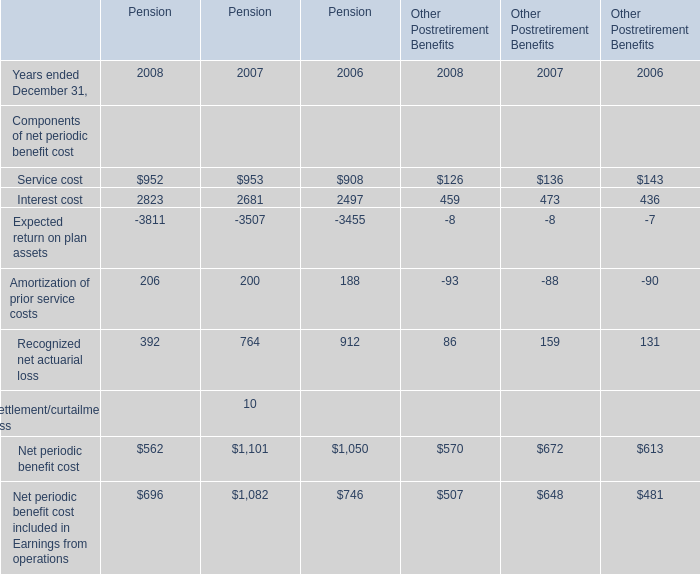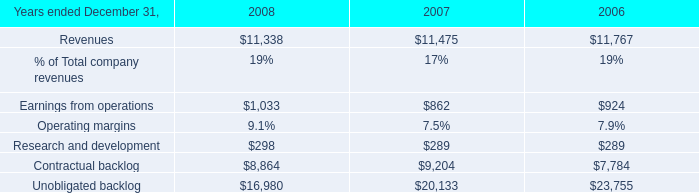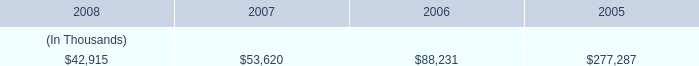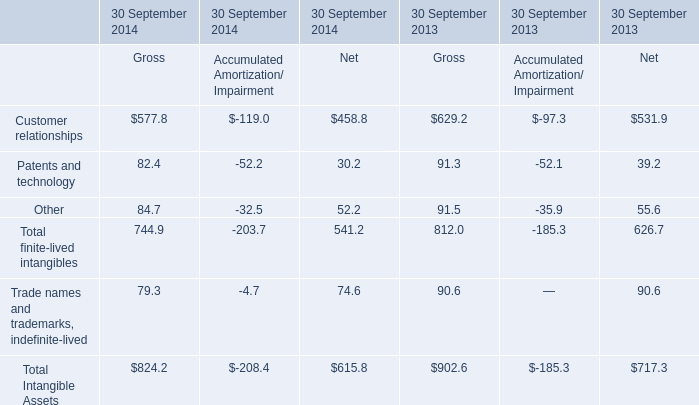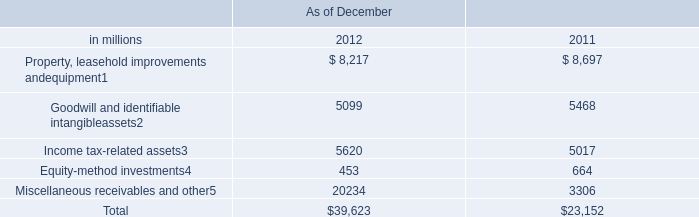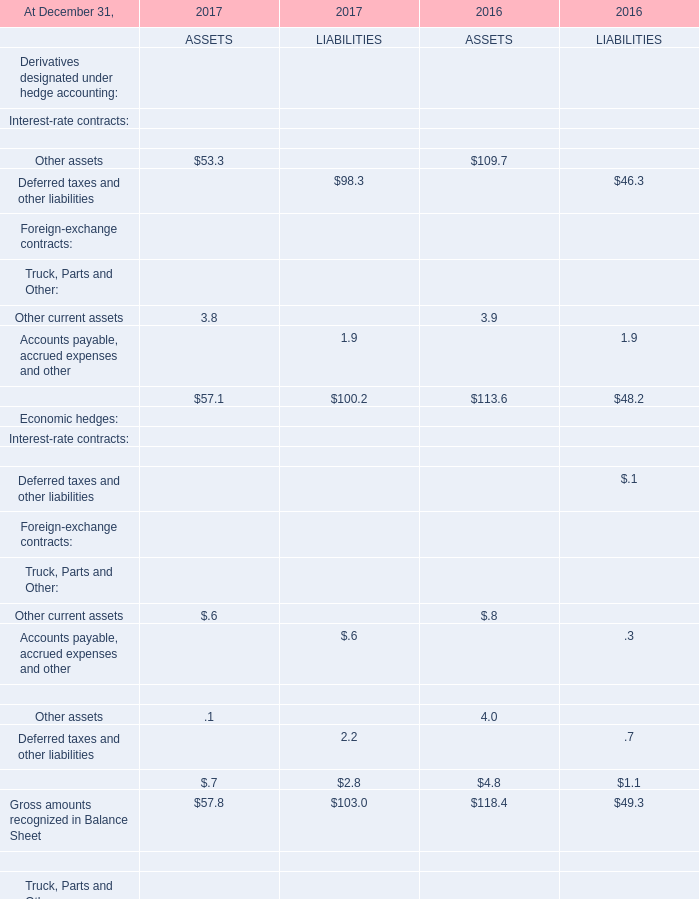What is the average amount of Contractual backlog of 2007, and Expected return on plan assets of Pension 2008 ? 
Computations: ((9204.0 + 3811.0) / 2)
Answer: 6507.5. 